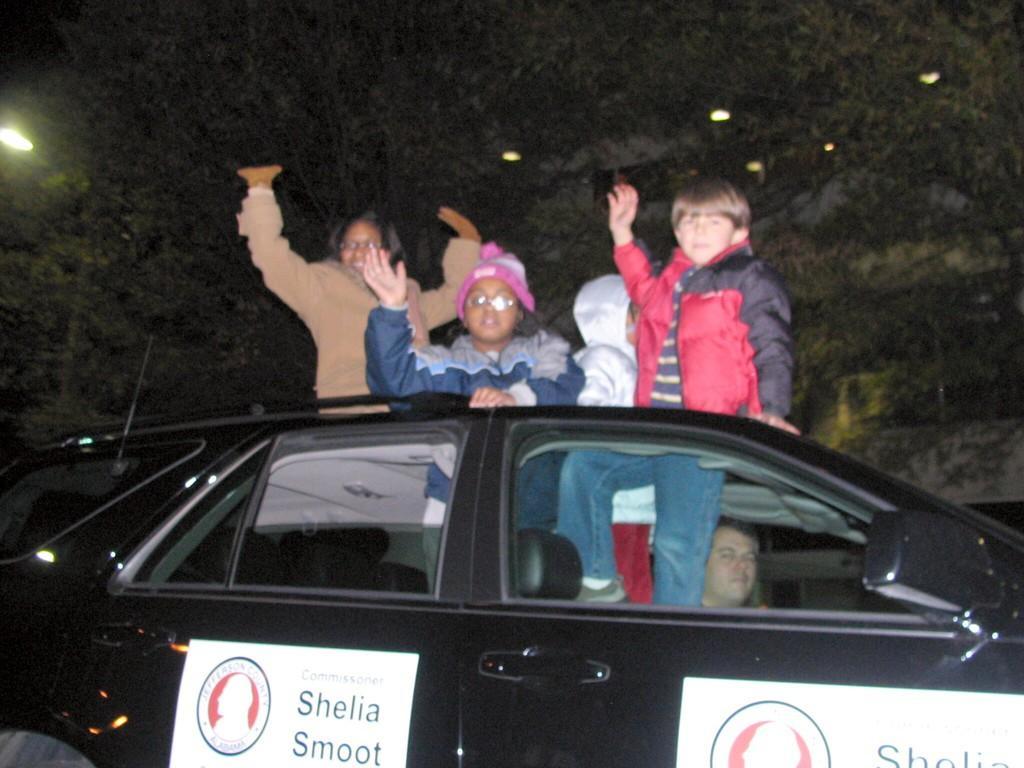In one or two sentences, can you explain what this image depicts? In this image i can see few people in a car, one of them is sitting in a driver seat and the other are standing out through the car, and in the background i can see trees and lights. 